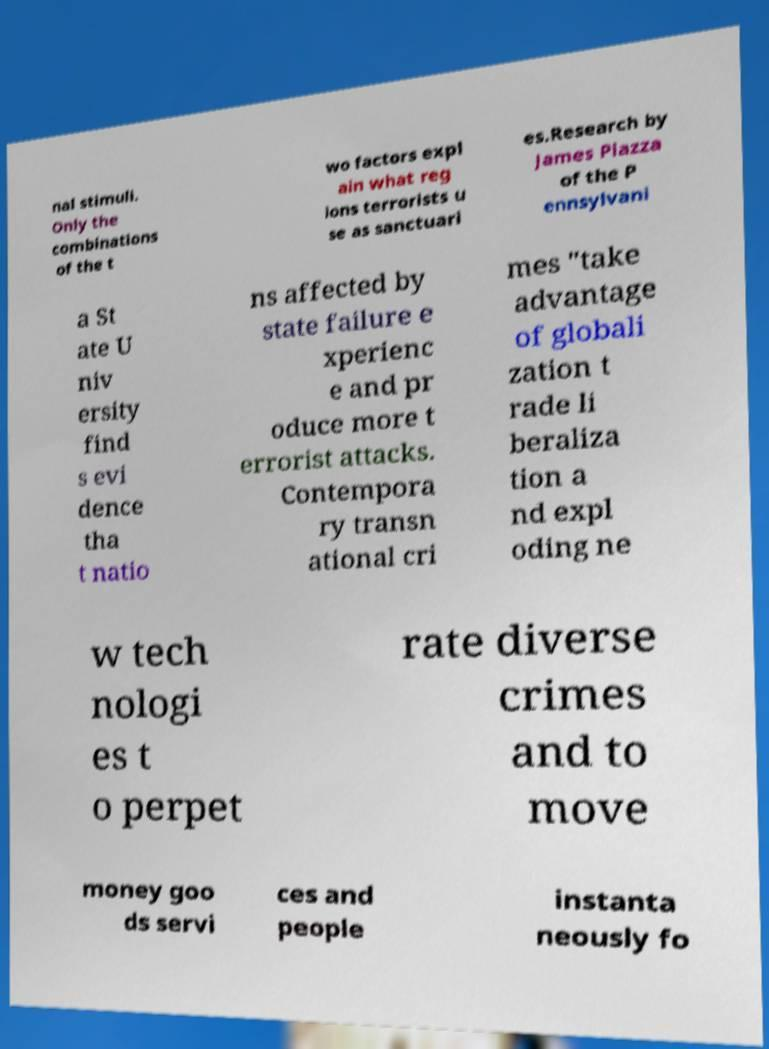For documentation purposes, I need the text within this image transcribed. Could you provide that? nal stimuli. Only the combinations of the t wo factors expl ain what reg ions terrorists u se as sanctuari es.Research by James Piazza of the P ennsylvani a St ate U niv ersity find s evi dence tha t natio ns affected by state failure e xperienc e and pr oduce more t errorist attacks. Contempora ry transn ational cri mes "take advantage of globali zation t rade li beraliza tion a nd expl oding ne w tech nologi es t o perpet rate diverse crimes and to move money goo ds servi ces and people instanta neously fo 